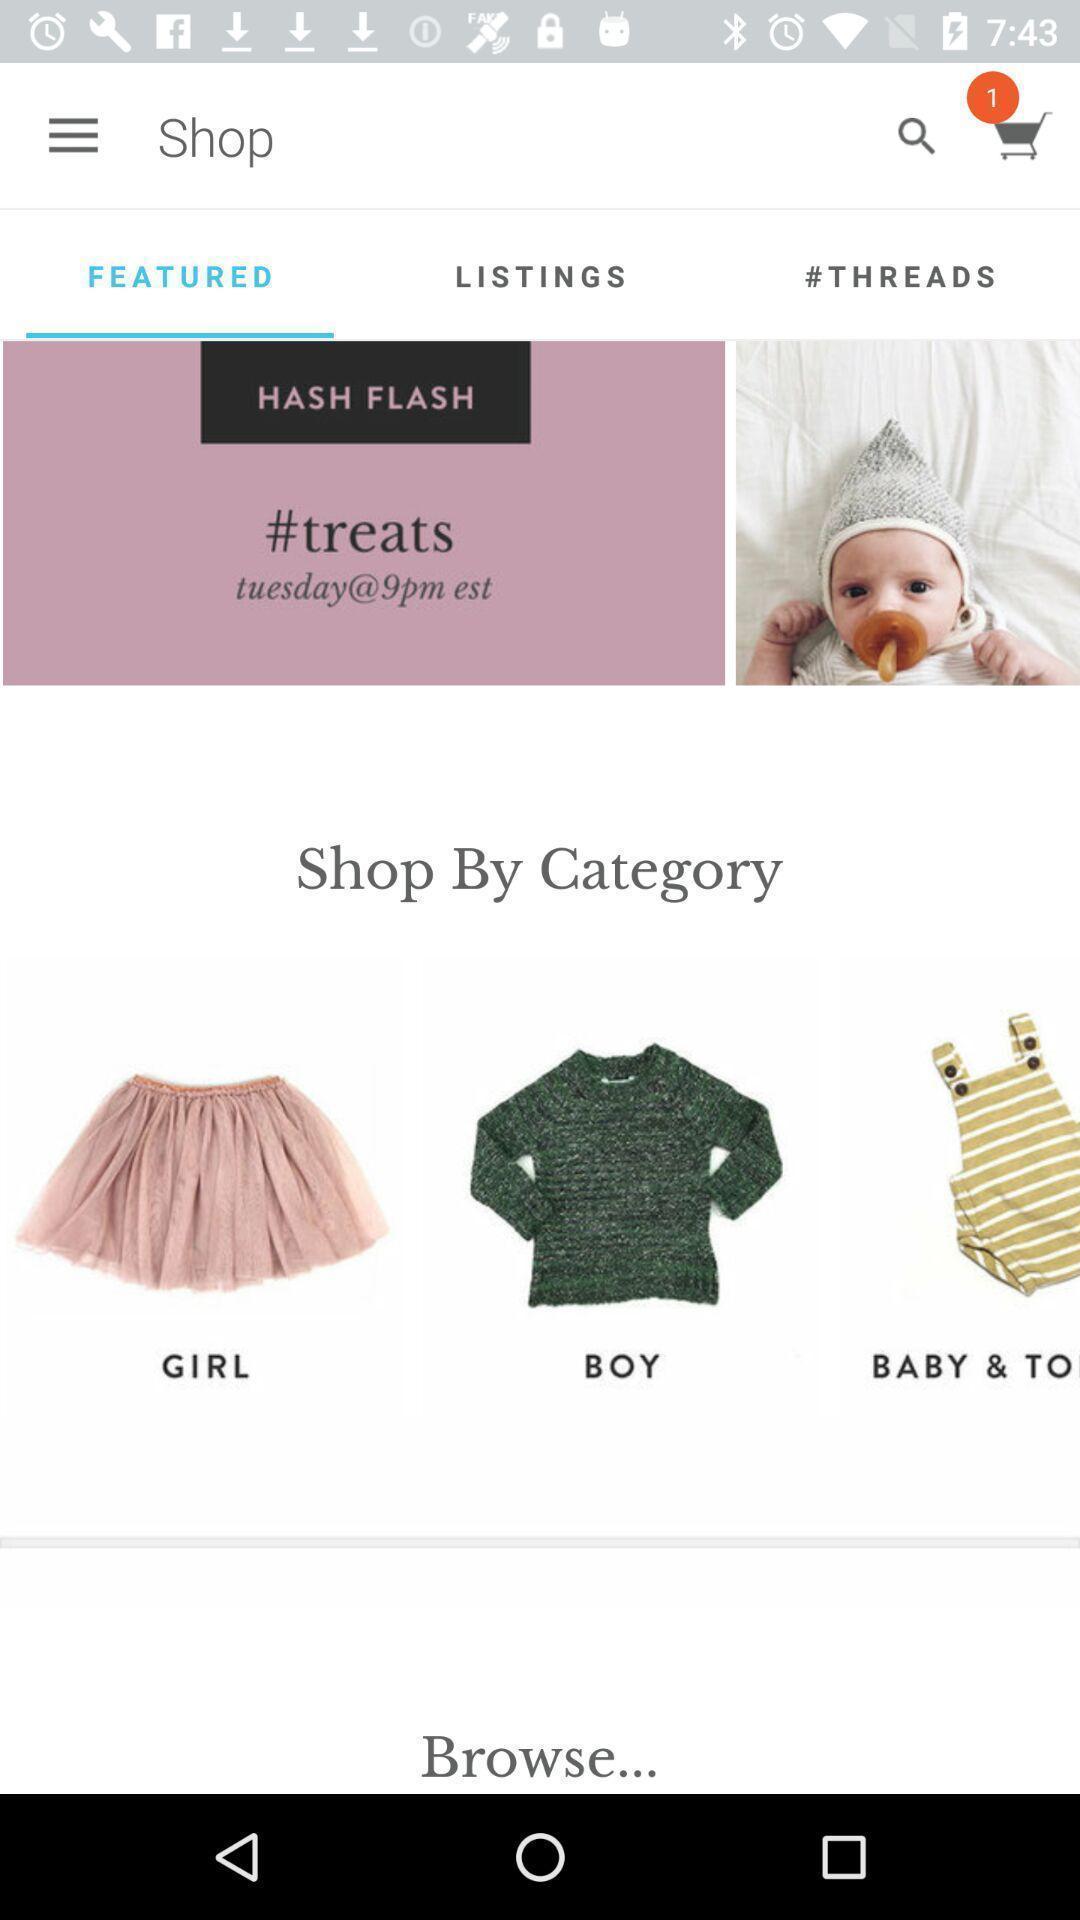Tell me about the visual elements in this screen capture. Screen shows multiple product options in a shopping application. 